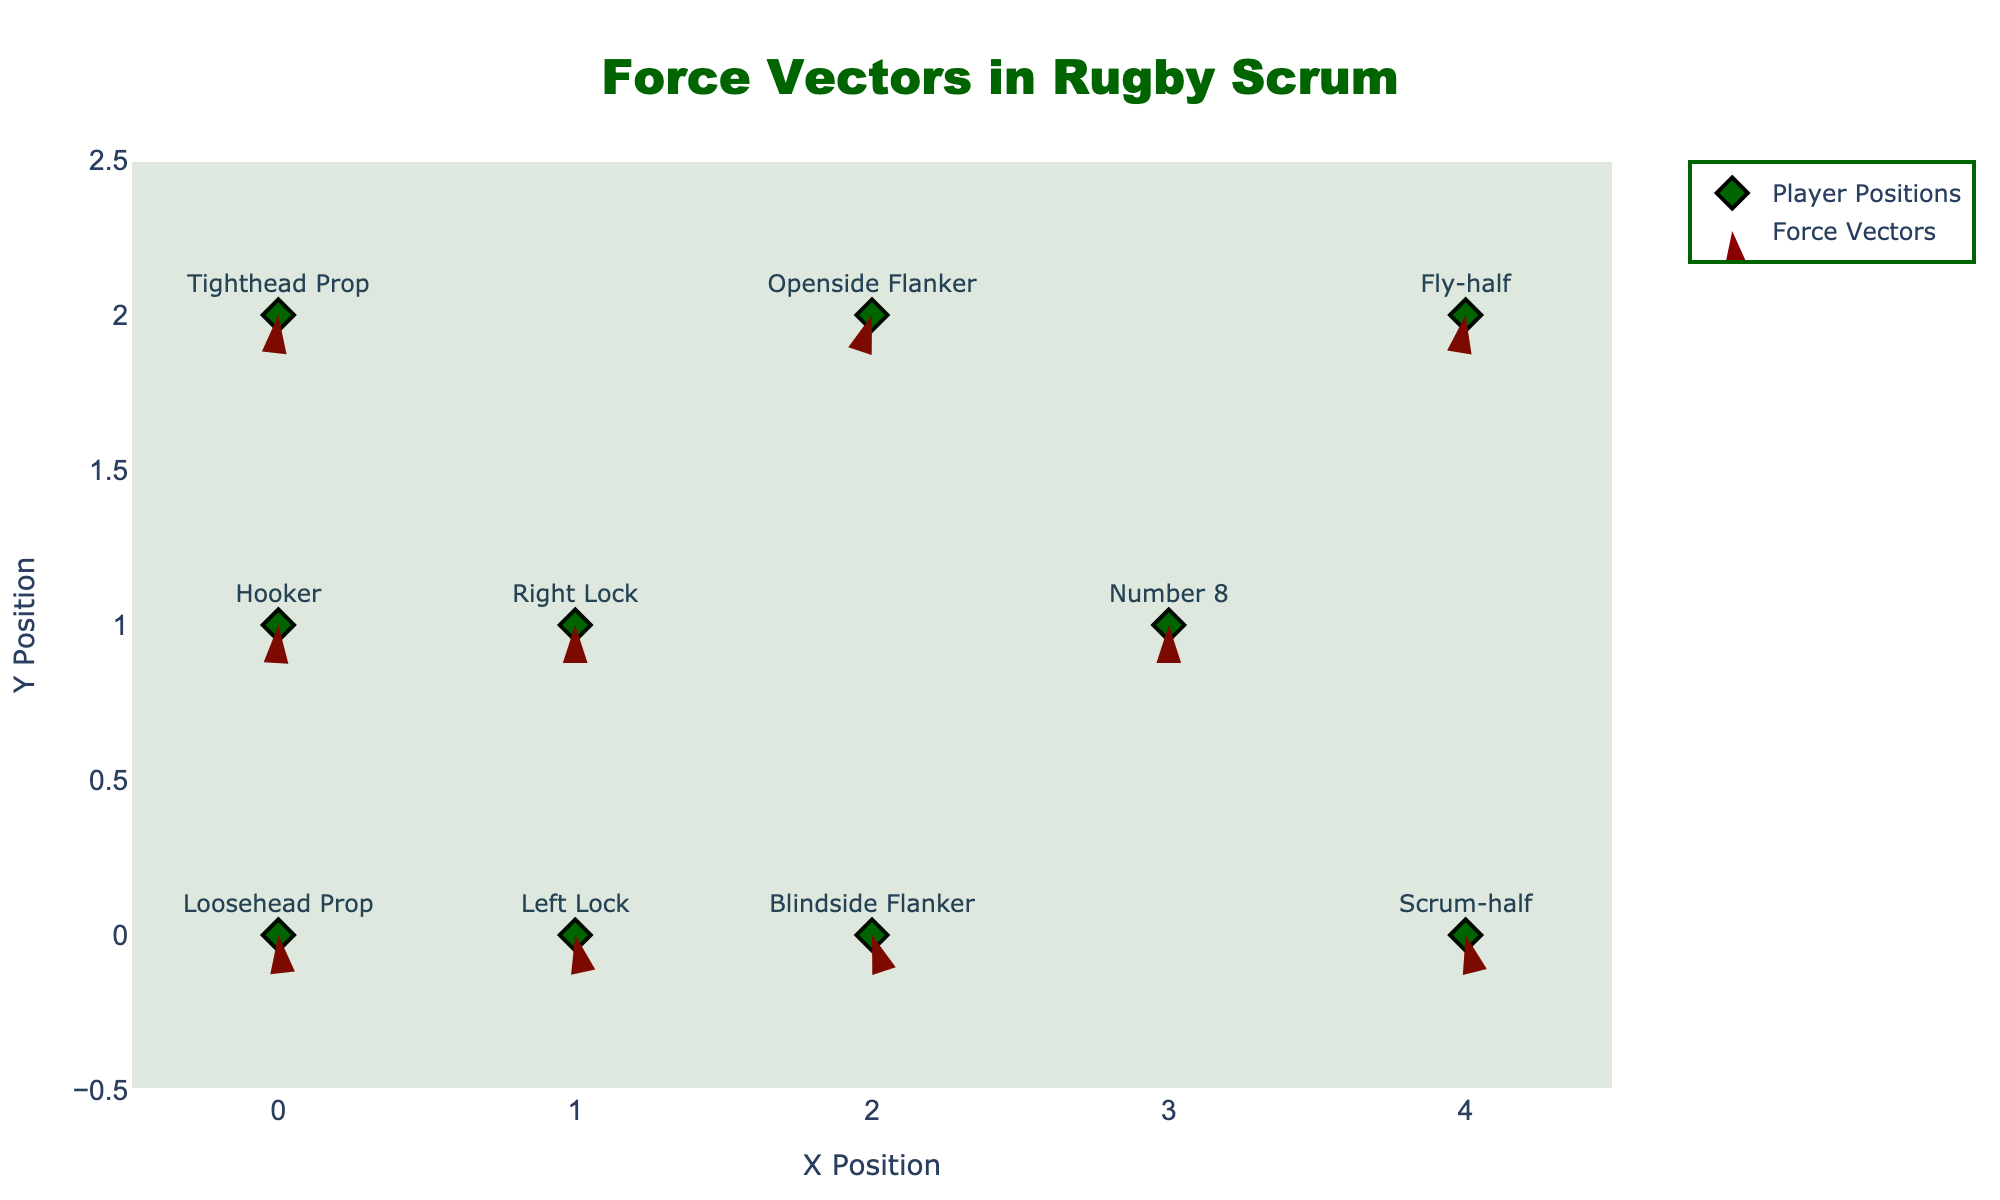What is the title of the figure? The title of the figure is usually displayed at the top center of the chart. The title helps to understand the overall subject or theme of the data being visualized. In this case, the title indicates that the figure is about force vectors in a rugby scrum.
Answer: Force Vectors in Rugby Scrum Which player experiences the highest forward force? To determine the highest forward force, look for the vector with the largest positive horizontal component (u-value) among the players. The player with the position "Loosehead Prop" has the highest forward force with a u-value of 450.
Answer: Loosehead Prop At which positions do the forces have both positive horizontal and vertical components? Positive horizontal and vertical components mean both u and v values are positive. By inspecting the data, players at positions "Loosehead Prop," "Left Lock," and "Scrum-half" have both positive u and v components.
Answer: Loosehead Prop, Left Lock, Scrum-half Calculate the average horizontal force (u) applied by the front row (Loosehead Prop, Hooker, Tighthead Prop)? The front row includes "Loosehead Prop," "Hooker," and "Tighthead Prop." Their horizontal forces (u) are 450, 400, and 450, respectively. Sum these values to get 450 + 400 + 450 = 1300. Divide by 3 to find the average, which is 1300 / 3.
Answer: 433.33 Which player faces the strongest opposite vertical force compared to the "Number 8" player? Compare the v-values of the players to the "Number 8" who has vertical force v=0. The "Openside Flanker" with a v-value of -100 faces the strongest opposite vertical force in comparison.
Answer: Openside Flanker What is the difference in horizontal force (u) between the "Blindside Flanker" and "Openside Flanker"? Look at their horizontal forces (u). "Blindside Flanker" has 300 and "Openside Flanker" also has 300. The difference is calculated as 300 - 300 = 0.
Answer: 0 Compare the magnitude of resultant forces for "Loosehead Prop" and "Tighthead Prop". Who has a larger vector? The magnitude of the resultant force is calculated as √(u² + v²). "Loosehead Prop": √(450² + 50²) = √(202500 + 2500) = √205000 = 452.76, "Tighthead Prop": √(450² + (-50)²) = √(202500 + 2500) = √205000 = 452.76. Both have the same magnitude.
Answer: Equal 